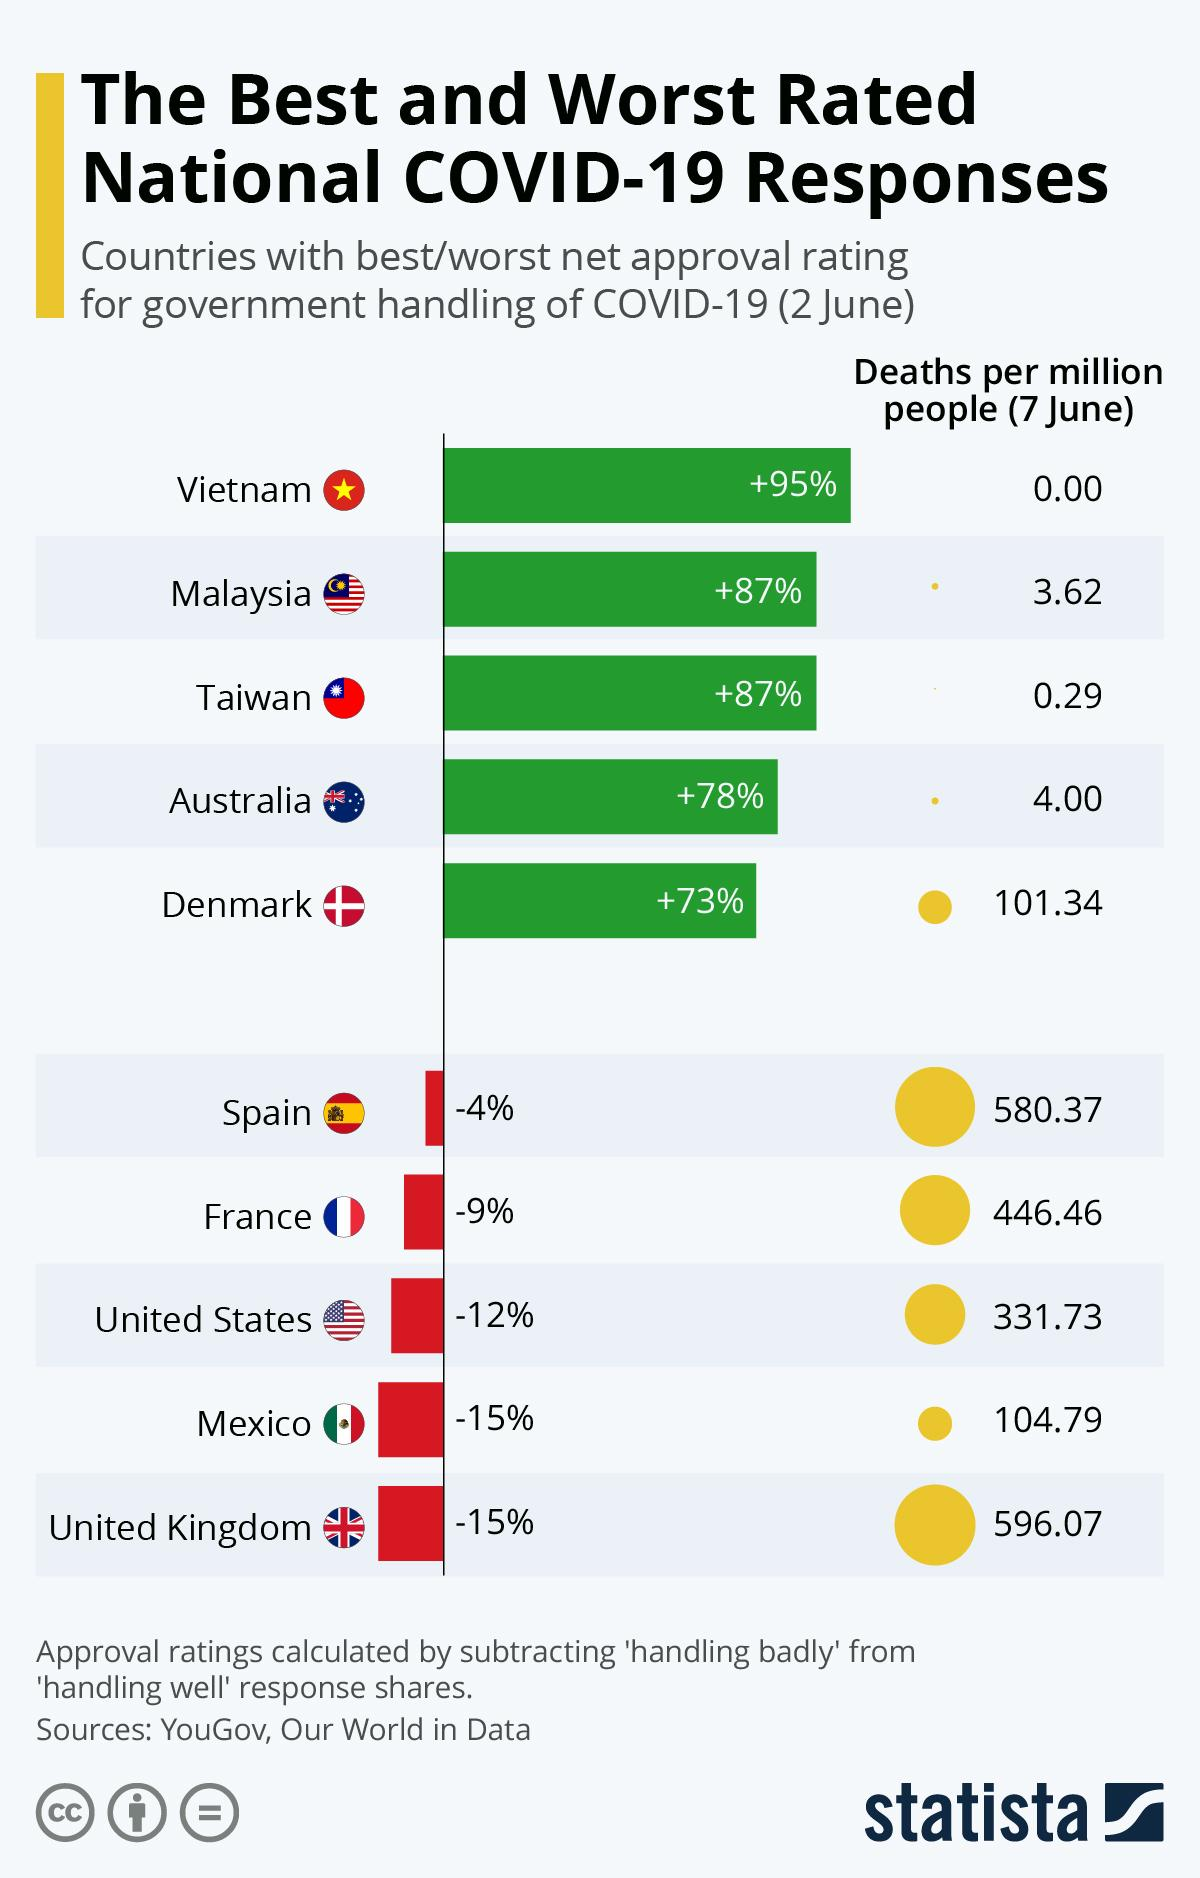Point out several critical features in this image. The government's handling of COVID-19 in Spain has a negative approval rating of -4% as of 2 June. The United Kingdom has the highest number of deaths per million people as of 7 June. As of 7 June, the number of deaths per million people in Denmark is 101.34. The government's handling of COVID-19 in Australia has received a net approval rating of +78% as of 2 June. According to data from 2 June, Vietnam has the best net approval rating for the government's handling of COVID-19. 